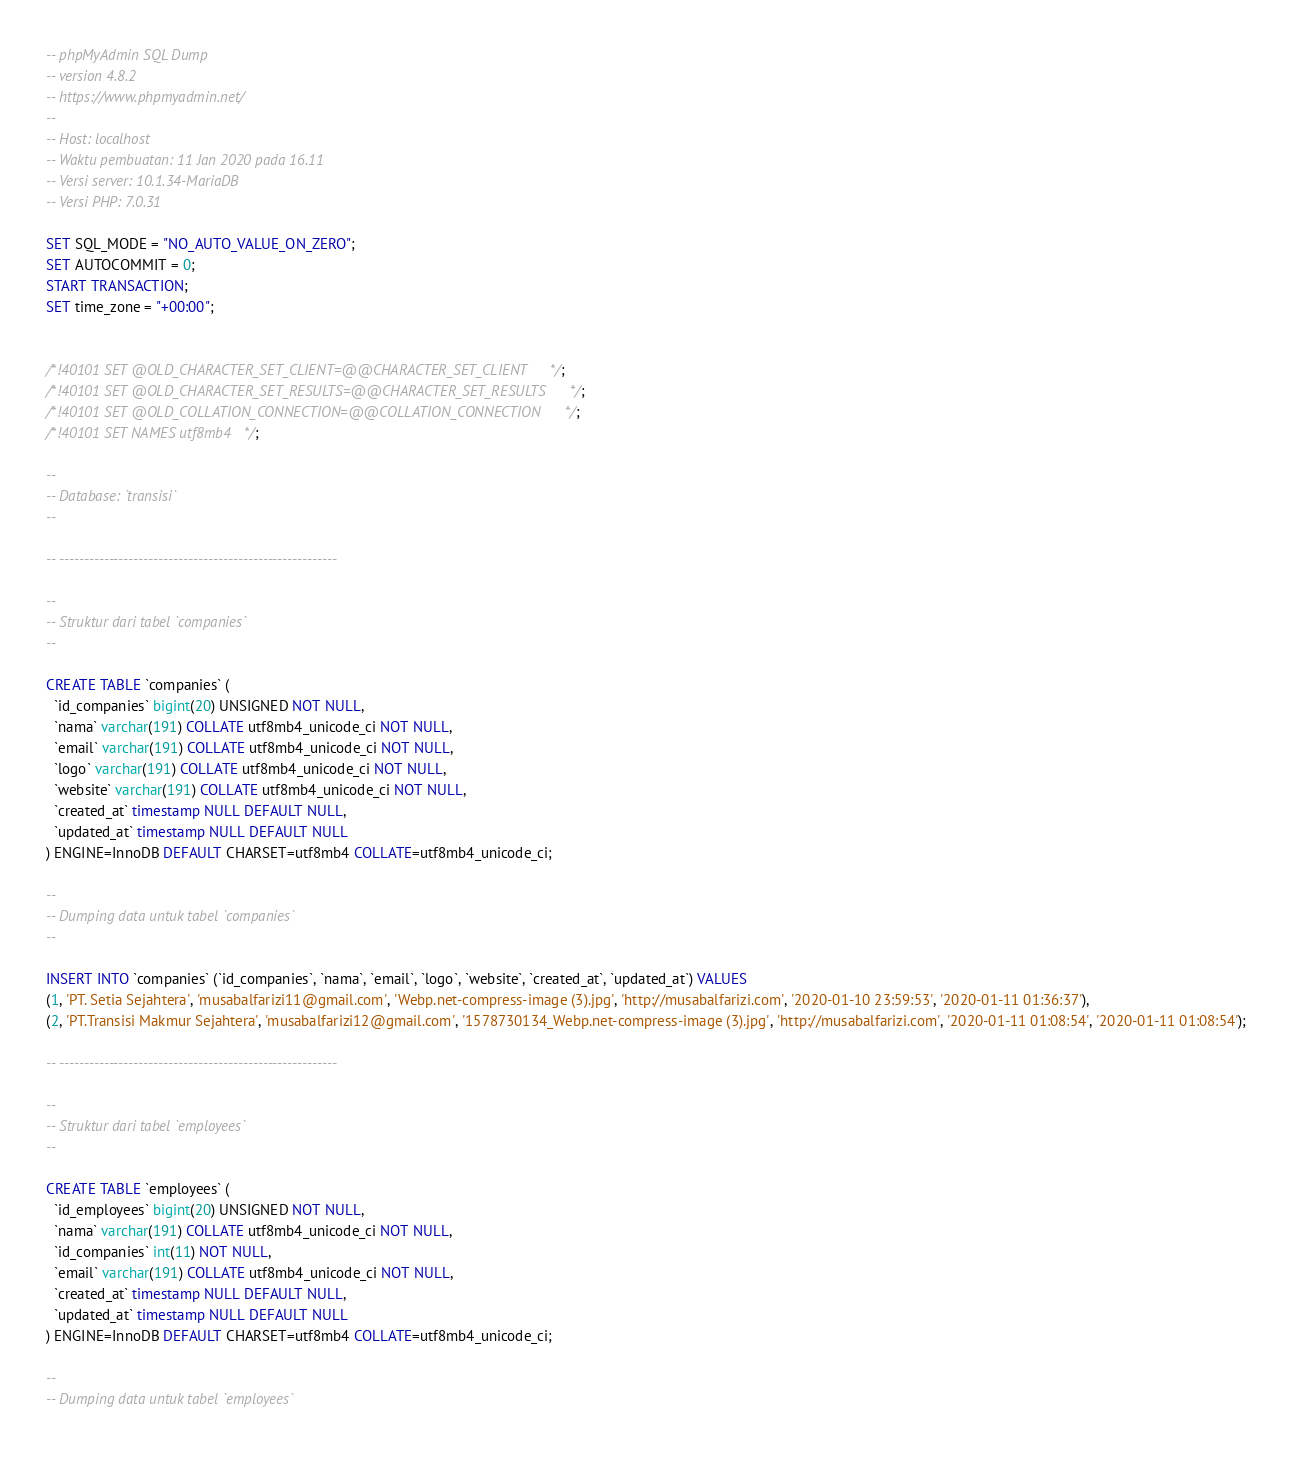Convert code to text. <code><loc_0><loc_0><loc_500><loc_500><_SQL_>-- phpMyAdmin SQL Dump
-- version 4.8.2
-- https://www.phpmyadmin.net/
--
-- Host: localhost
-- Waktu pembuatan: 11 Jan 2020 pada 16.11
-- Versi server: 10.1.34-MariaDB
-- Versi PHP: 7.0.31

SET SQL_MODE = "NO_AUTO_VALUE_ON_ZERO";
SET AUTOCOMMIT = 0;
START TRANSACTION;
SET time_zone = "+00:00";


/*!40101 SET @OLD_CHARACTER_SET_CLIENT=@@CHARACTER_SET_CLIENT */;
/*!40101 SET @OLD_CHARACTER_SET_RESULTS=@@CHARACTER_SET_RESULTS */;
/*!40101 SET @OLD_COLLATION_CONNECTION=@@COLLATION_CONNECTION */;
/*!40101 SET NAMES utf8mb4 */;

--
-- Database: `transisi`
--

-- --------------------------------------------------------

--
-- Struktur dari tabel `companies`
--

CREATE TABLE `companies` (
  `id_companies` bigint(20) UNSIGNED NOT NULL,
  `nama` varchar(191) COLLATE utf8mb4_unicode_ci NOT NULL,
  `email` varchar(191) COLLATE utf8mb4_unicode_ci NOT NULL,
  `logo` varchar(191) COLLATE utf8mb4_unicode_ci NOT NULL,
  `website` varchar(191) COLLATE utf8mb4_unicode_ci NOT NULL,
  `created_at` timestamp NULL DEFAULT NULL,
  `updated_at` timestamp NULL DEFAULT NULL
) ENGINE=InnoDB DEFAULT CHARSET=utf8mb4 COLLATE=utf8mb4_unicode_ci;

--
-- Dumping data untuk tabel `companies`
--

INSERT INTO `companies` (`id_companies`, `nama`, `email`, `logo`, `website`, `created_at`, `updated_at`) VALUES
(1, 'PT. Setia Sejahtera', 'musabalfarizi11@gmail.com', 'Webp.net-compress-image (3).jpg', 'http://musabalfarizi.com', '2020-01-10 23:59:53', '2020-01-11 01:36:37'),
(2, 'PT.Transisi Makmur Sejahtera', 'musabalfarizi12@gmail.com', '1578730134_Webp.net-compress-image (3).jpg', 'http://musabalfarizi.com', '2020-01-11 01:08:54', '2020-01-11 01:08:54');

-- --------------------------------------------------------

--
-- Struktur dari tabel `employees`
--

CREATE TABLE `employees` (
  `id_employees` bigint(20) UNSIGNED NOT NULL,
  `nama` varchar(191) COLLATE utf8mb4_unicode_ci NOT NULL,
  `id_companies` int(11) NOT NULL,
  `email` varchar(191) COLLATE utf8mb4_unicode_ci NOT NULL,
  `created_at` timestamp NULL DEFAULT NULL,
  `updated_at` timestamp NULL DEFAULT NULL
) ENGINE=InnoDB DEFAULT CHARSET=utf8mb4 COLLATE=utf8mb4_unicode_ci;

--
-- Dumping data untuk tabel `employees`</code> 